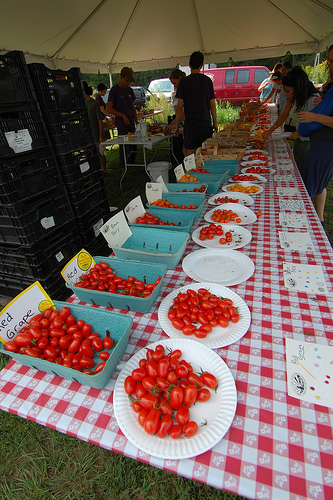<image>
Is the table under the plate? Yes. The table is positioned underneath the plate, with the plate above it in the vertical space. Is there a red grape to the left of the guy? Yes. From this viewpoint, the red grape is positioned to the left side relative to the guy. 